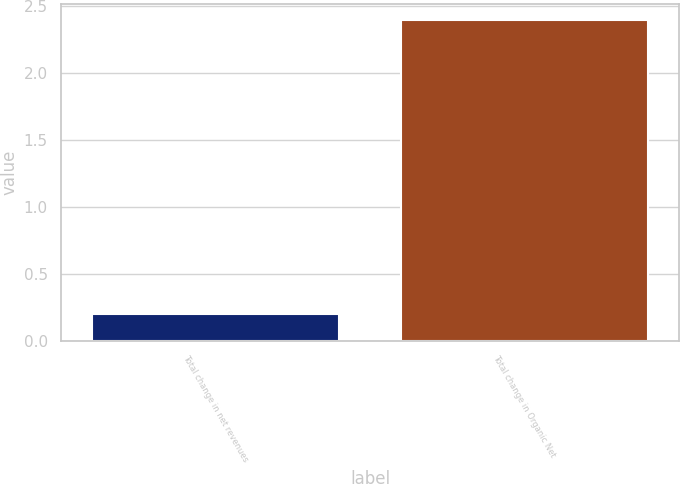<chart> <loc_0><loc_0><loc_500><loc_500><bar_chart><fcel>Total change in net revenues<fcel>Total change in Organic Net<nl><fcel>0.2<fcel>2.4<nl></chart> 